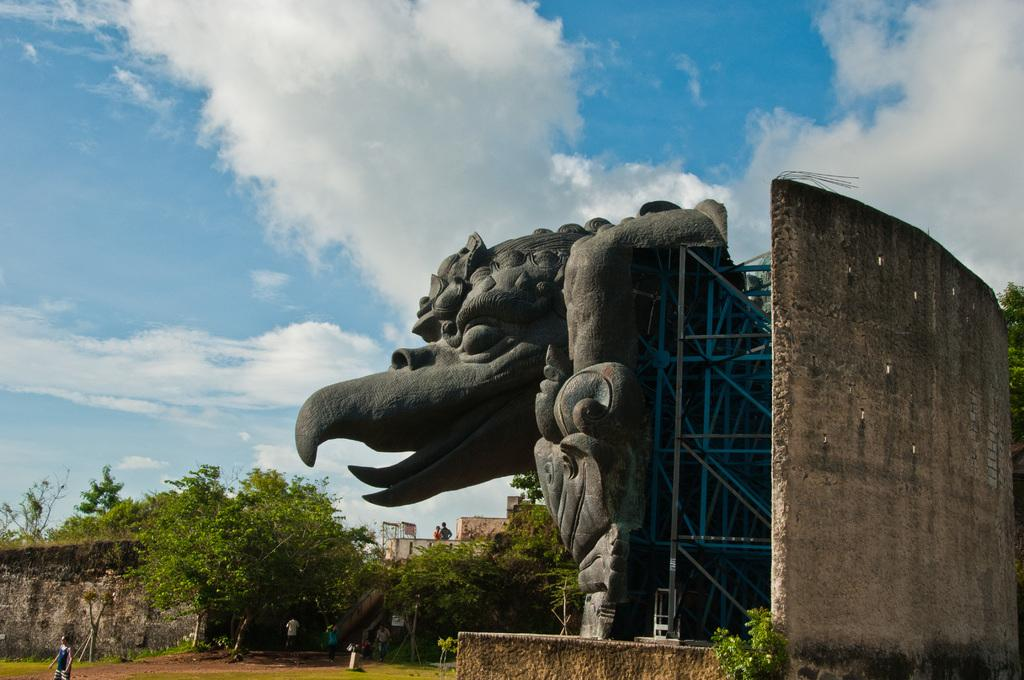What is the main subject in the image? There is a statue in the image. What else can be seen in the image besides the statue? There is a group of trees, poles, a group of persons standing on the ground, and the sky visible in the background. How many poles are visible in the image? The number of poles is not specified, but there are poles present in the image. What is the condition of the sky in the image? The sky appears to be cloudy in the image. What type of drug is being administered to the statue in the image? There is no drug present in the image, and the statue is not receiving any treatment. 